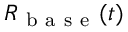<formula> <loc_0><loc_0><loc_500><loc_500>R _ { b a s e } ( t )</formula> 